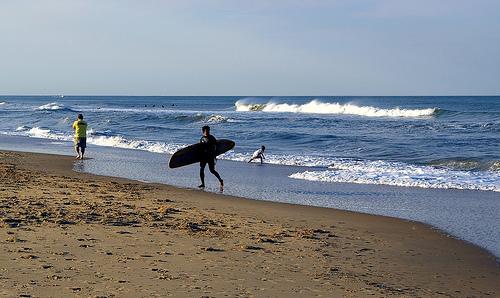How many kids in the photo?
Quick response, please. 1. What kind of water is in the picture?
Give a very brief answer. Ocean. Are there any large waves coming to shore?
Be succinct. Yes. How many kites are being flown?
Short answer required. 0. Who is going into the water?
Concise answer only. Child. 